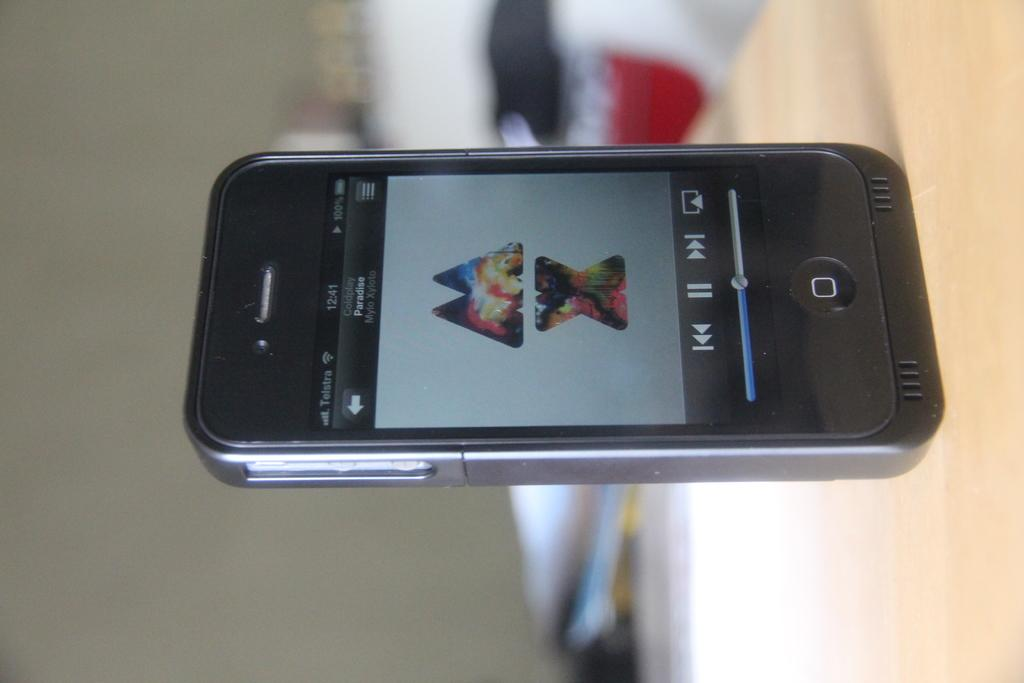<image>
Relay a brief, clear account of the picture shown. A phone displaying the letters M and X with pictures inside is sitting sideways. 